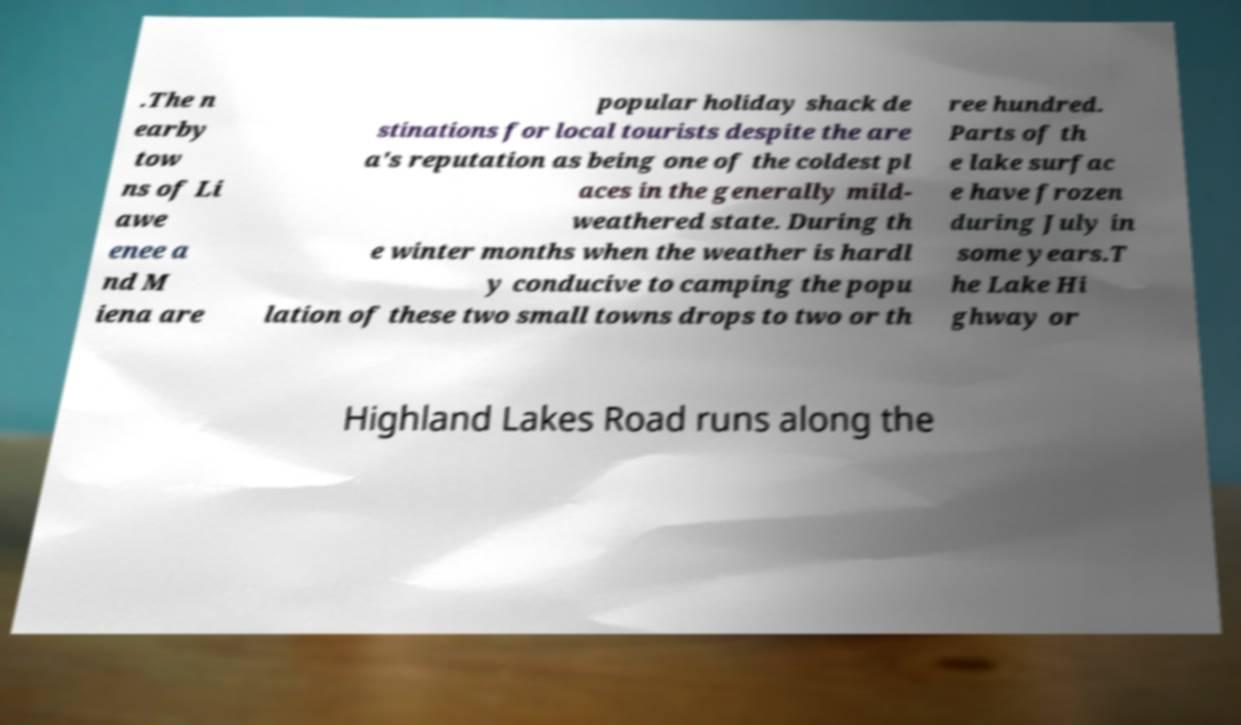Can you read and provide the text displayed in the image?This photo seems to have some interesting text. Can you extract and type it out for me? .The n earby tow ns of Li awe enee a nd M iena are popular holiday shack de stinations for local tourists despite the are a's reputation as being one of the coldest pl aces in the generally mild- weathered state. During th e winter months when the weather is hardl y conducive to camping the popu lation of these two small towns drops to two or th ree hundred. Parts of th e lake surfac e have frozen during July in some years.T he Lake Hi ghway or Highland Lakes Road runs along the 